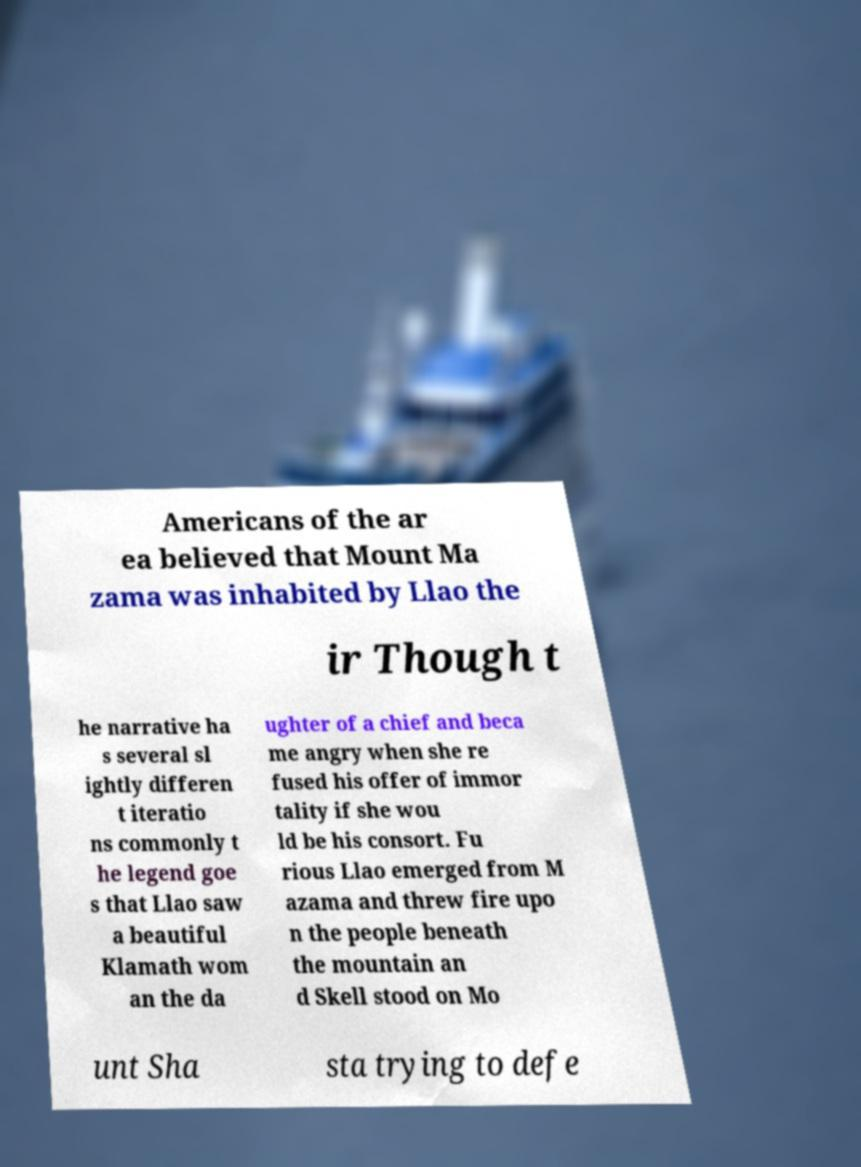Could you extract and type out the text from this image? Americans of the ar ea believed that Mount Ma zama was inhabited by Llao the ir Though t he narrative ha s several sl ightly differen t iteratio ns commonly t he legend goe s that Llao saw a beautiful Klamath wom an the da ughter of a chief and beca me angry when she re fused his offer of immor tality if she wou ld be his consort. Fu rious Llao emerged from M azama and threw fire upo n the people beneath the mountain an d Skell stood on Mo unt Sha sta trying to defe 